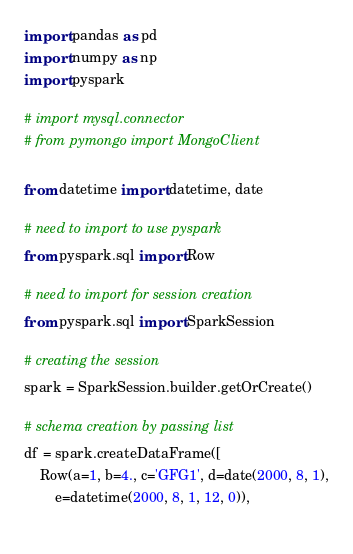Convert code to text. <code><loc_0><loc_0><loc_500><loc_500><_Python_>import pandas as pd
import numpy as np
import pyspark

# import mysql.connector
# from pymongo import MongoClient

from datetime import datetime, date
  
# need to import to use pyspark
from pyspark.sql import Row
  
# need to import for session creation
from pyspark.sql import SparkSession
  
# creating the session
spark = SparkSession.builder.getOrCreate()
  
# schema creation by passing list
df = spark.createDataFrame([
    Row(a=1, b=4., c='GFG1', d=date(2000, 8, 1),
        e=datetime(2000, 8, 1, 12, 0)),
    </code> 